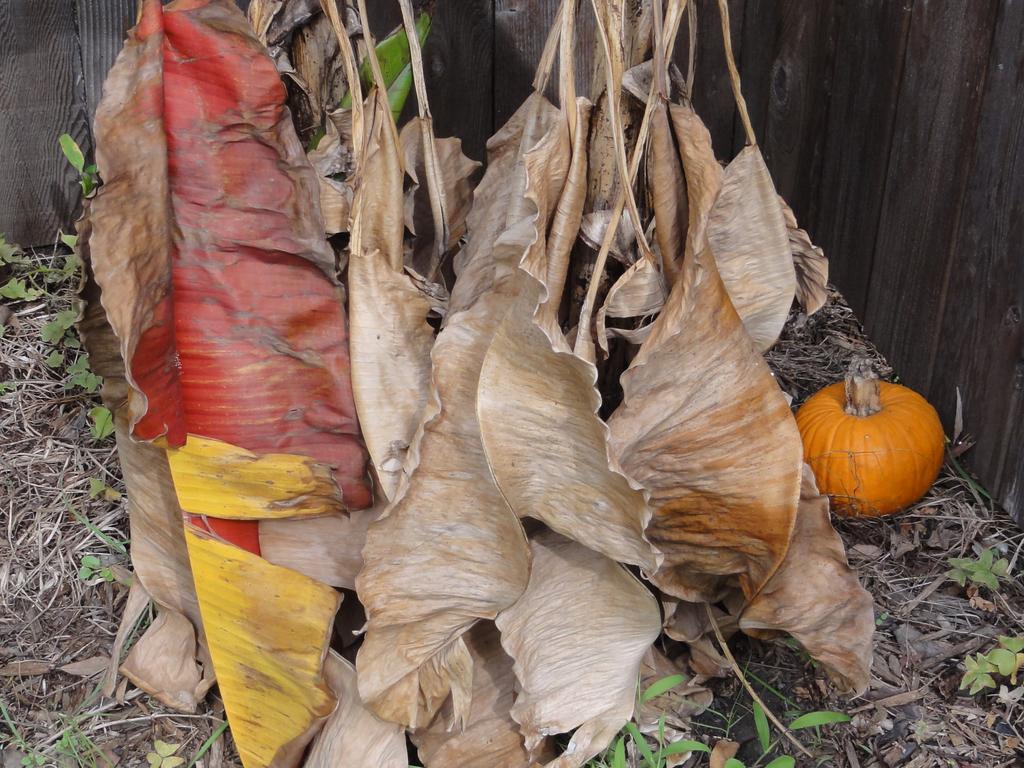Could you give a brief overview of what you see in this image? In this image we can see, there are so many dry leaves hanging, and also there are some plants on the ground and on the right side we can see a vegetable. 